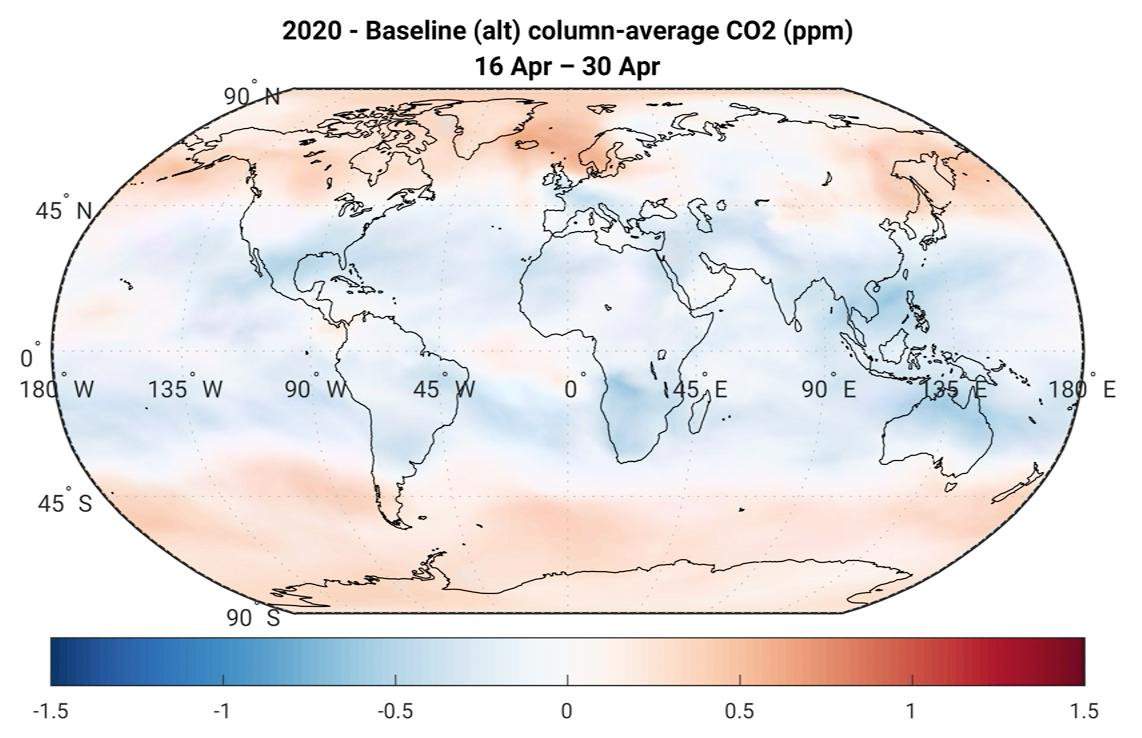List a handful of essential elements in this visual. The color of the equator region is blue. It is more prominent on the poles to observe pink rather than blue. 